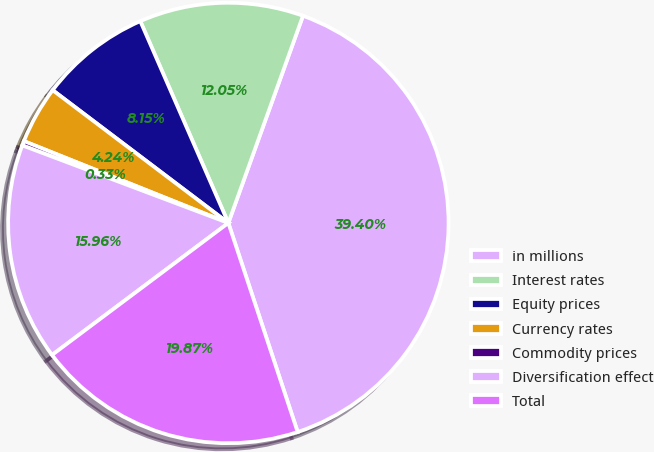Convert chart. <chart><loc_0><loc_0><loc_500><loc_500><pie_chart><fcel>in millions<fcel>Interest rates<fcel>Equity prices<fcel>Currency rates<fcel>Commodity prices<fcel>Diversification effect<fcel>Total<nl><fcel>39.4%<fcel>12.05%<fcel>8.15%<fcel>4.24%<fcel>0.33%<fcel>15.96%<fcel>19.87%<nl></chart> 